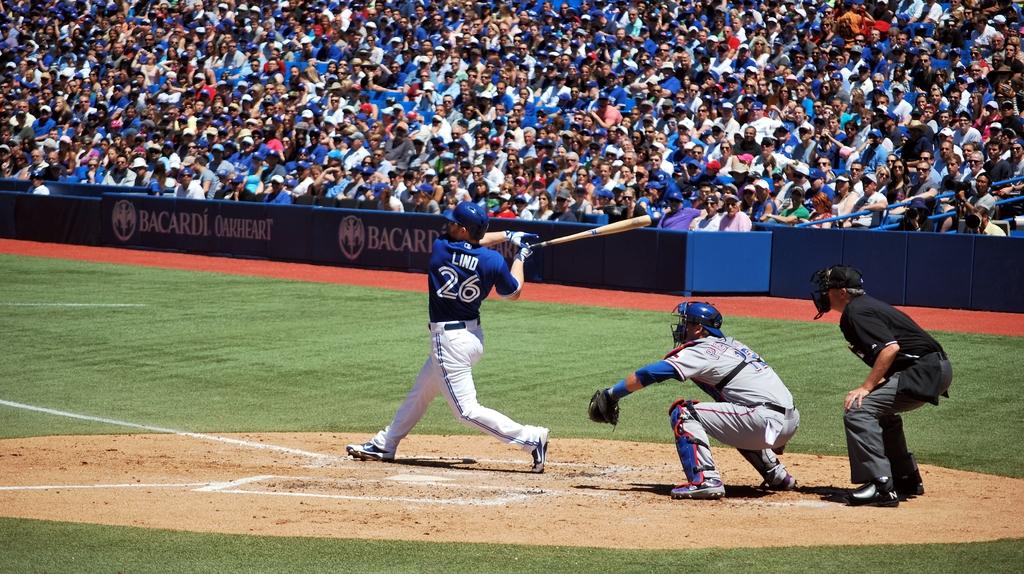Who is at bat?
Offer a terse response. Lind. What number is the jersey of the batter?
Your answer should be very brief. 26. 